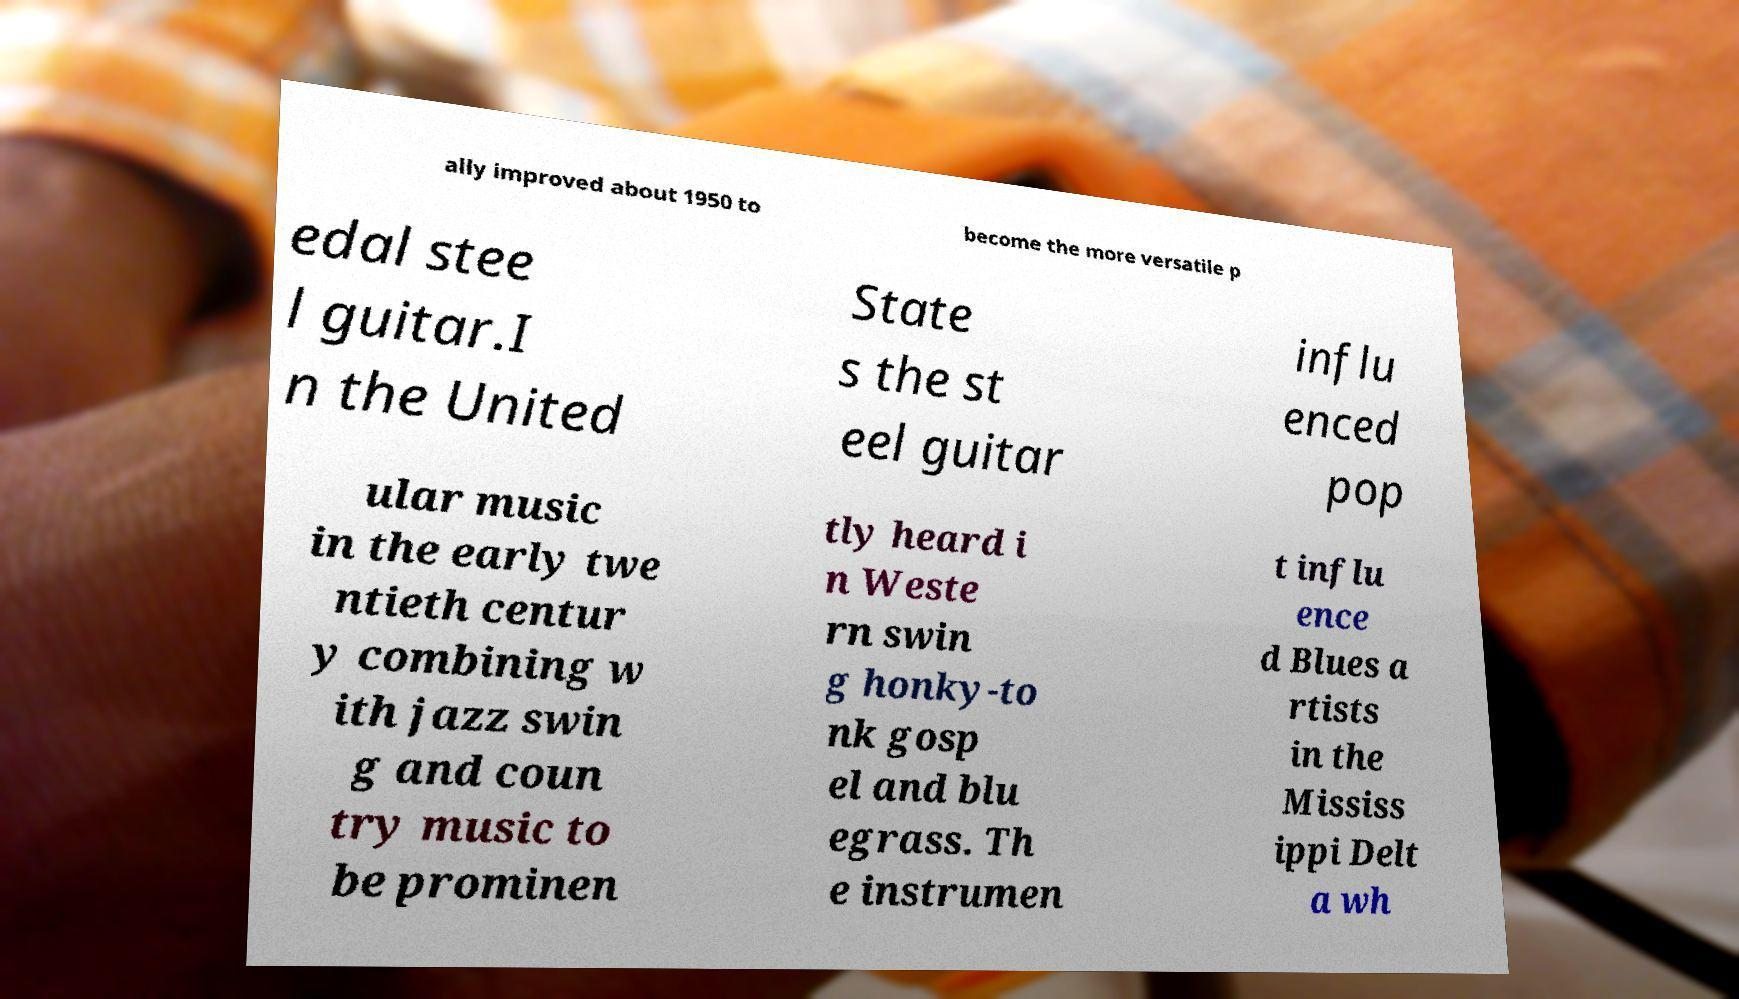There's text embedded in this image that I need extracted. Can you transcribe it verbatim? ally improved about 1950 to become the more versatile p edal stee l guitar.I n the United State s the st eel guitar influ enced pop ular music in the early twe ntieth centur y combining w ith jazz swin g and coun try music to be prominen tly heard i n Weste rn swin g honky-to nk gosp el and blu egrass. Th e instrumen t influ ence d Blues a rtists in the Mississ ippi Delt a wh 